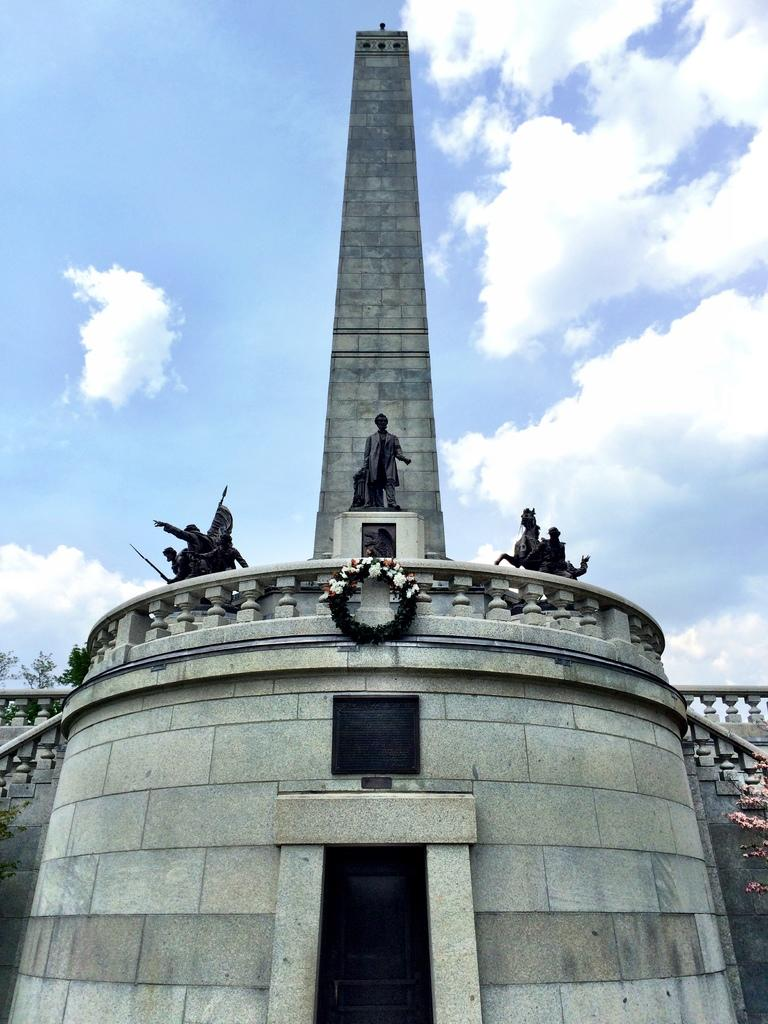What type of structure is present in the image? There is a building in the image. What other objects can be seen near the building? There are statues of people and animals in the image. What decoration is present in front of the building? There is a garland in front of the building. What can be seen in the background of the image? The sky is visible in the image. What type of trade is being conducted in the image? There is no indication of any trade being conducted in the image. How many kittens are visible in the image? There are no kittens present in the image. 